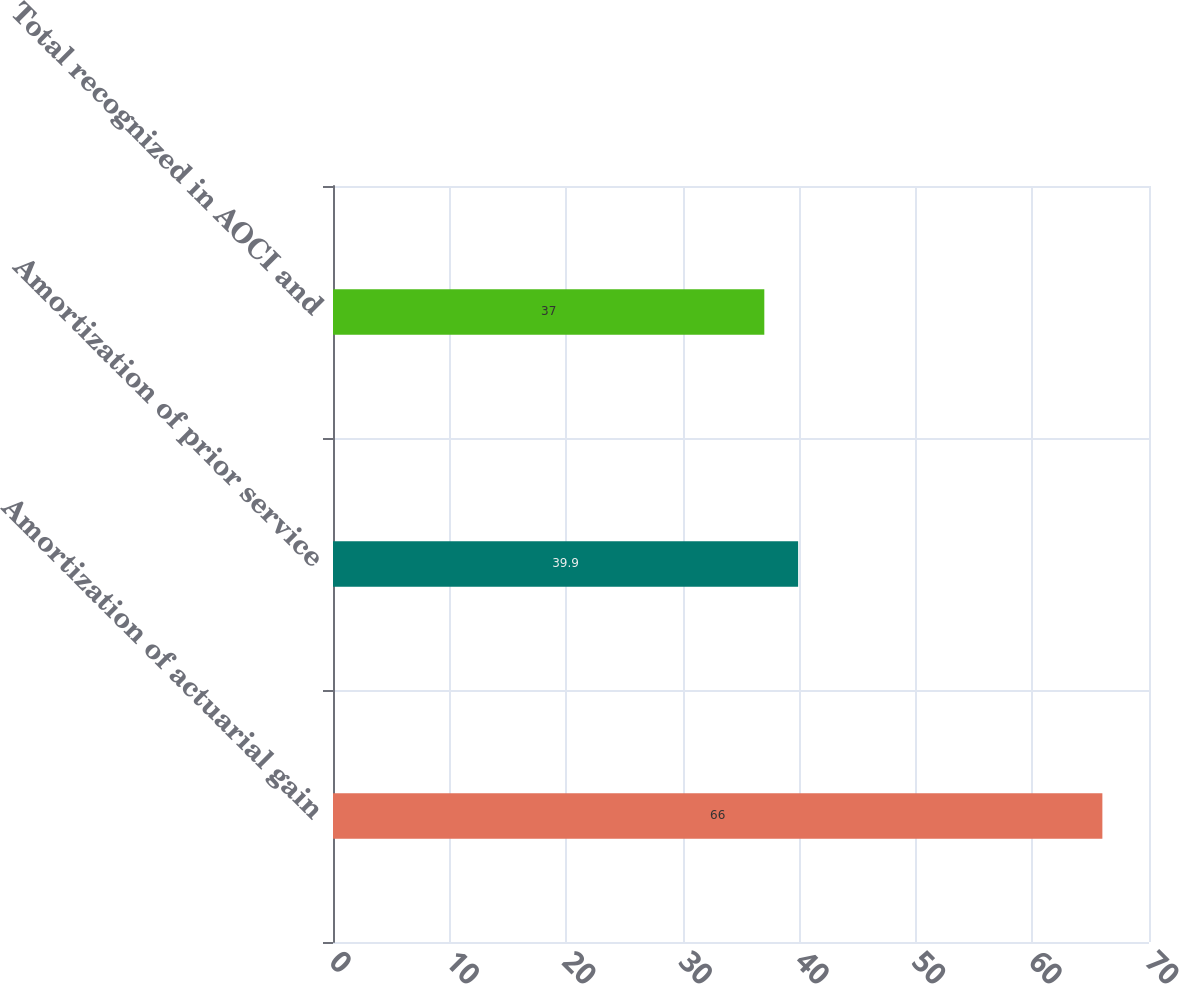Convert chart. <chart><loc_0><loc_0><loc_500><loc_500><bar_chart><fcel>Amortization of actuarial gain<fcel>Amortization of prior service<fcel>Total recognized in AOCI and<nl><fcel>66<fcel>39.9<fcel>37<nl></chart> 